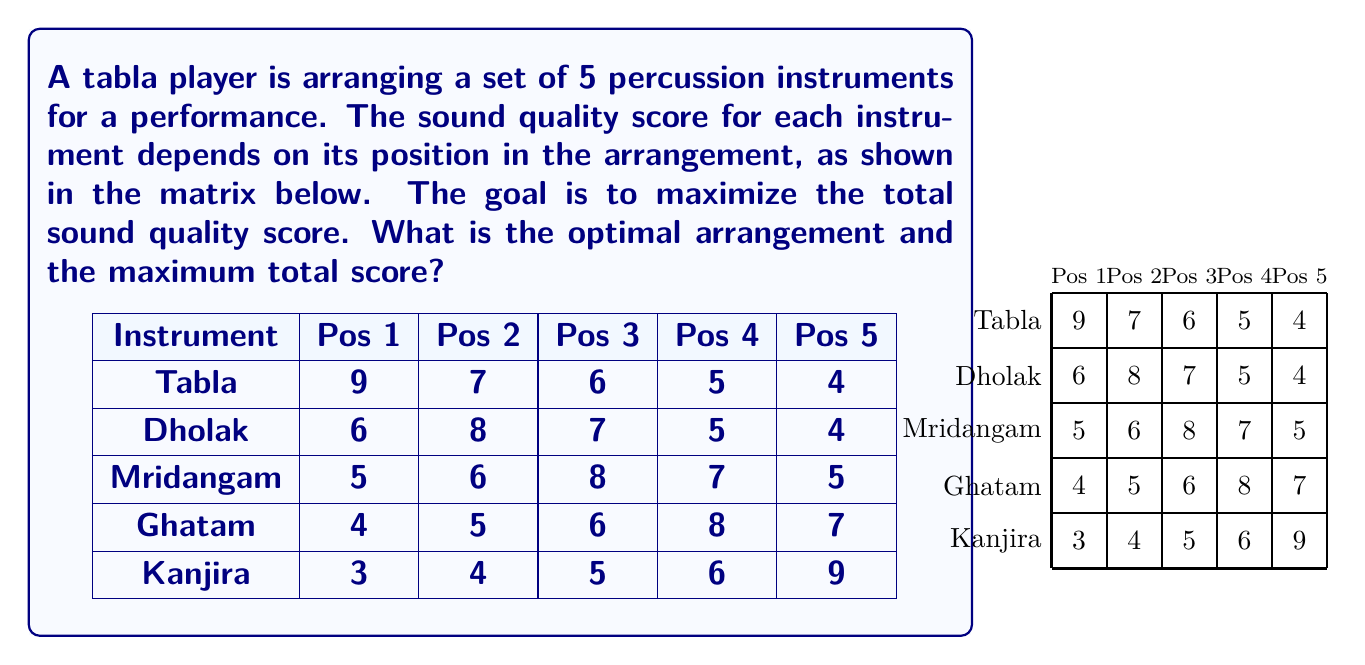Solve this math problem. To solve this problem, we'll use the Hungarian algorithm, which is an optimization method for assignment problems. The steps are as follows:

1) First, we need to convert this maximization problem into a minimization problem. We do this by subtracting each element from the largest element in the matrix (9):

$$
\begin{array}{c|ccccc}
\text{Instrument} & \text{Pos 1} & \text{Pos 2} & \text{Pos 3} & \text{Pos 4} & \text{Pos 5} \\
\hline
\text{Tabla} & 0 & 2 & 3 & 4 & 5 \\
\text{Dholak} & 3 & 1 & 2 & 4 & 5 \\
\text{Mridangam} & 4 & 3 & 1 & 2 & 4 \\
\text{Ghatam} & 5 & 4 & 3 & 1 & 2 \\
\text{Kanjira} & 6 & 5 & 4 & 3 & 0 \\
\end{array}
$$

2) Subtract the smallest element in each row from all elements in that row:

$$
\begin{array}{c|ccccc}
\text{Instrument} & \text{Pos 1} & \text{Pos 2} & \text{Pos 3} & \text{Pos 4} & \text{Pos 5} \\
\hline
\text{Tabla} & 0 & 2 & 3 & 4 & 5 \\
\text{Dholak} & 2 & 0 & 1 & 3 & 4 \\
\text{Mridangam} & 3 & 2 & 0 & 1 & 3 \\
\text{Ghatam} & 4 & 3 & 2 & 0 & 1 \\
\text{Kanjira} & 6 & 5 & 4 & 3 & 0 \\
\end{array}
$$

3) Subtract the smallest element in each column from all elements in that column:

$$
\begin{array}{c|ccccc}
\text{Instrument} & \text{Pos 1} & \text{Pos 2} & \text{Pos 3} & \text{Pos 4} & \text{Pos 5} \\
\hline
\text{Tabla} & 0 & 2 & 3 & 4 & 5 \\
\text{Dholak} & 2 & 0 & 1 & 3 & 4 \\
\text{Mridangam} & 3 & 2 & 0 & 1 & 3 \\
\text{Ghatam} & 4 & 3 & 2 & 0 & 1 \\
\text{Kanjira} & 6 & 5 & 4 & 3 & 0 \\
\end{array}
$$

4) Draw lines through rows and columns to cover all zeros using the minimum number of lines:

$$
\begin{array}{c|ccccc}
\text{Instrument} & \text{Pos 1} & \text{Pos 2} & \text{Pos 3} & \text{Pos 4} & \text{Pos 5} \\
\hline
\text{Tabla} & \underline{0} & 2 & 3 & 4 & 5 \\
\text{Dholak} & 2 & \underline{0} & 1 & 3 & 4 \\
\text{Mridangam} & 3 & 2 & \underline{0} & 1 & 3 \\
\text{Ghatam} & 4 & 3 & 2 & \underline{0} & 1 \\
\text{Kanjira} & 6 & 5 & 4 & 3 & \underline{0} \\
\end{array}
$$

5) Since we have 5 lines (equal to the number of rows/columns), we have found the optimal solution.

6) The optimal assignment is:
   Tabla -> Position 1 (score: 9)
   Dholak -> Position 2 (score: 8)
   Mridangam -> Position 3 (score: 8)
   Ghatam -> Position 4 (score: 8)
   Kanjira -> Position 5 (score: 9)

7) The total maximum score is: 9 + 8 + 8 + 8 + 9 = 42
Answer: Optimal arrangement: Tabla, Dholak, Mridangam, Ghatam, Kanjira. Maximum total score: 42. 